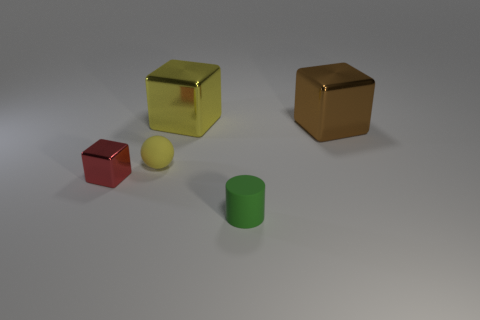Add 5 tiny yellow objects. How many objects exist? 10 Subtract all big cubes. How many cubes are left? 1 Subtract 0 brown cylinders. How many objects are left? 5 Subtract all cubes. How many objects are left? 2 Subtract 1 cubes. How many cubes are left? 2 Subtract all yellow blocks. Subtract all yellow cylinders. How many blocks are left? 2 Subtract all blue cylinders. How many blue balls are left? 0 Subtract all purple balls. Subtract all big yellow metallic cubes. How many objects are left? 4 Add 3 small red metal objects. How many small red metal objects are left? 4 Add 2 tiny metal cubes. How many tiny metal cubes exist? 3 